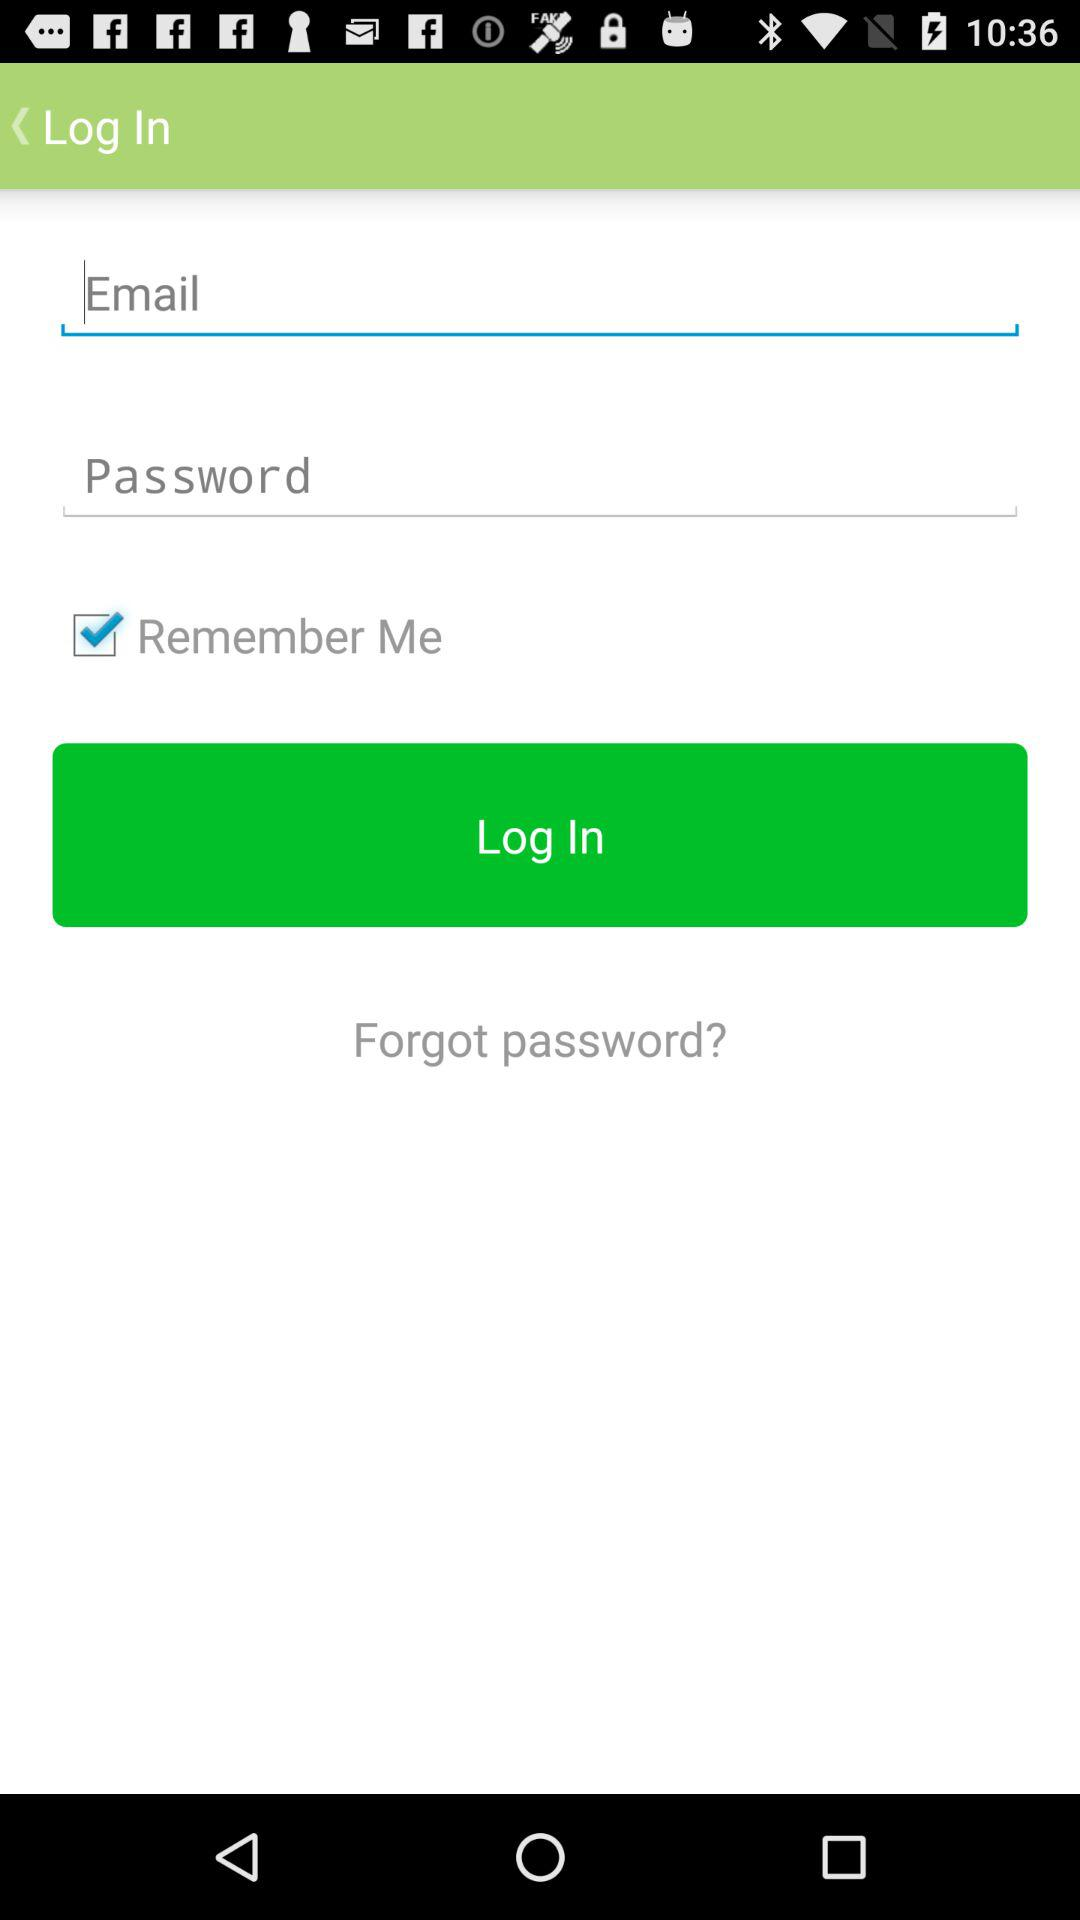What are the requirements to get a login? The requirements are "Email" and "Password". 